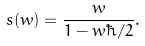<formula> <loc_0><loc_0><loc_500><loc_500>s ( w ) = \frac { w } { 1 - w \hbar { / } 2 } .</formula> 